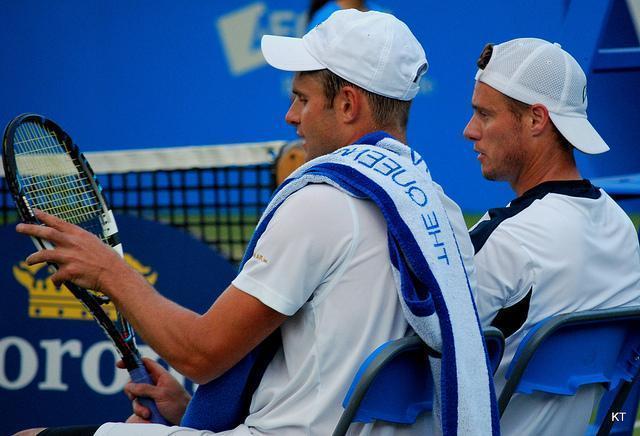How many people are in the photo?
Give a very brief answer. 2. How many chairs are in the photo?
Give a very brief answer. 2. 